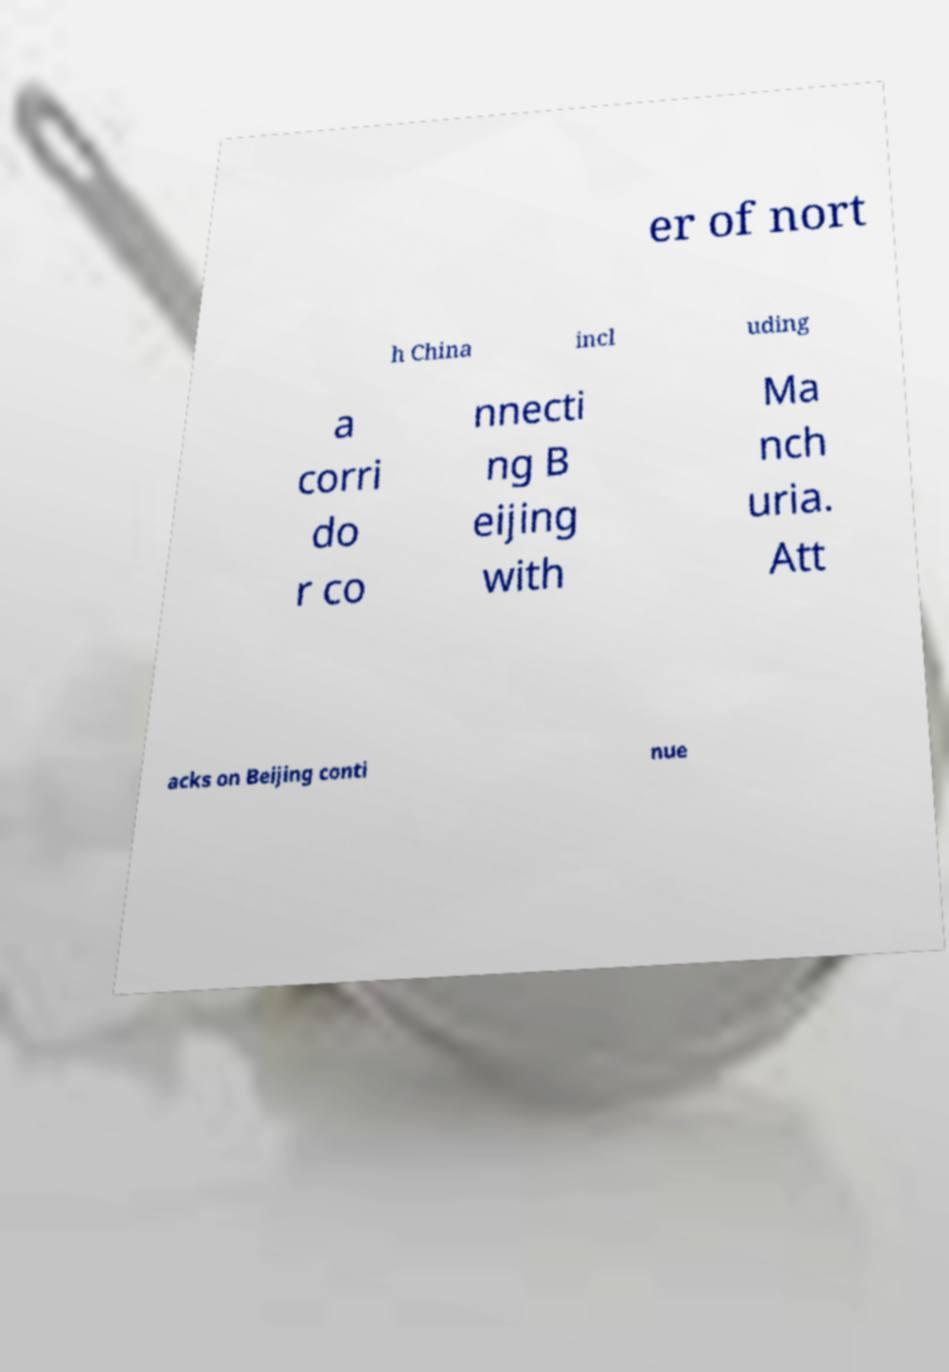What messages or text are displayed in this image? I need them in a readable, typed format. er of nort h China incl uding a corri do r co nnecti ng B eijing with Ma nch uria. Att acks on Beijing conti nue 